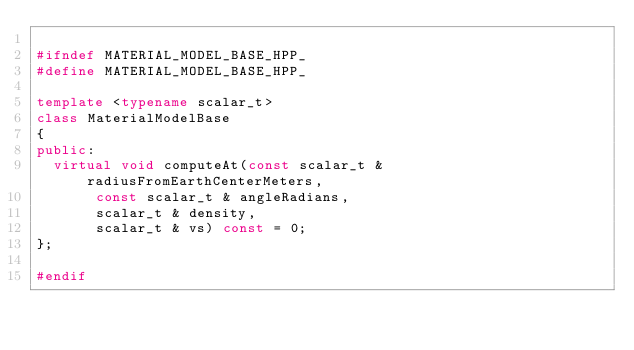<code> <loc_0><loc_0><loc_500><loc_500><_C++_>
#ifndef MATERIAL_MODEL_BASE_HPP_
#define MATERIAL_MODEL_BASE_HPP_

template <typename scalar_t>
class MaterialModelBase
{
public:
  virtual void computeAt(const scalar_t & radiusFromEarthCenterMeters,
			 const scalar_t & angleRadians,
			 scalar_t & density,
			 scalar_t & vs) const = 0;
};

#endif
</code> 